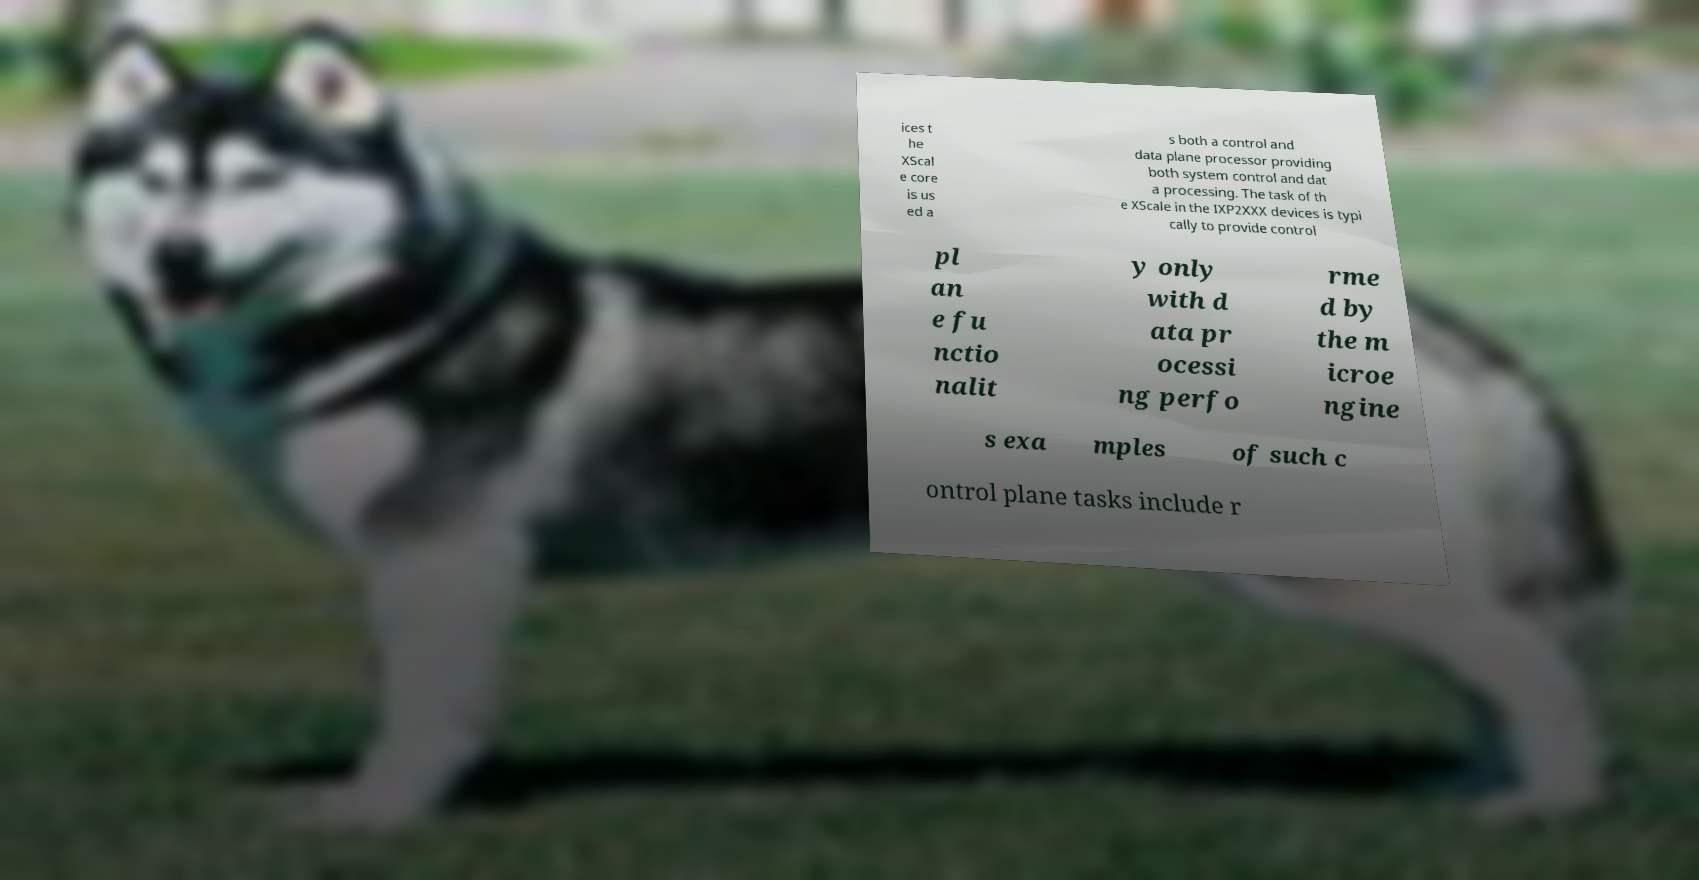Can you accurately transcribe the text from the provided image for me? ices t he XScal e core is us ed a s both a control and data plane processor providing both system control and dat a processing. The task of th e XScale in the IXP2XXX devices is typi cally to provide control pl an e fu nctio nalit y only with d ata pr ocessi ng perfo rme d by the m icroe ngine s exa mples of such c ontrol plane tasks include r 